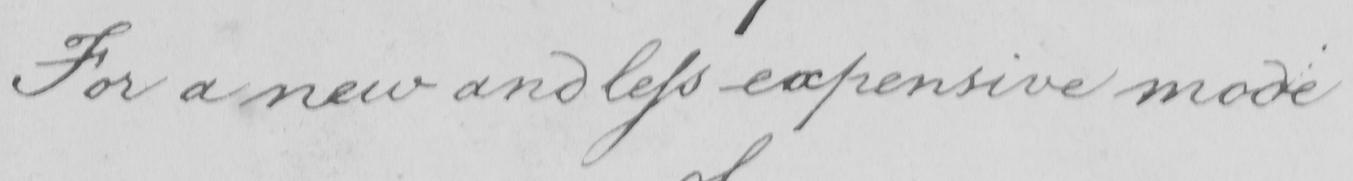Please provide the text content of this handwritten line. For a new and less expensive mode 